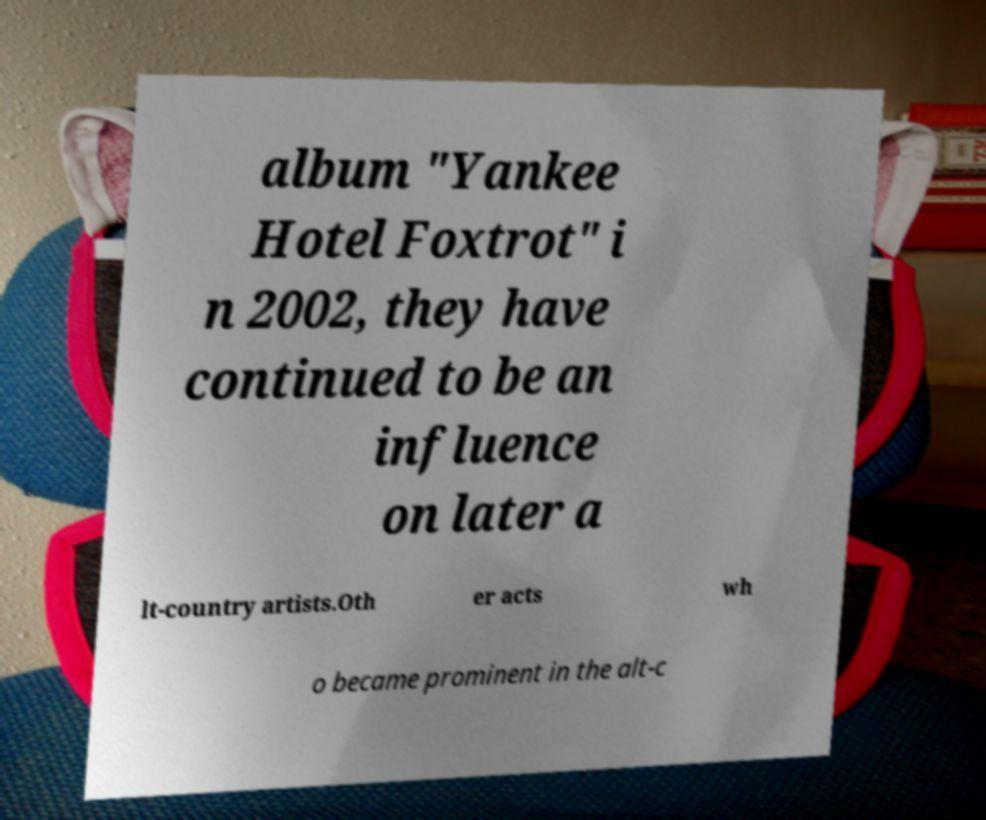Can you accurately transcribe the text from the provided image for me? album "Yankee Hotel Foxtrot" i n 2002, they have continued to be an influence on later a lt-country artists.Oth er acts wh o became prominent in the alt-c 